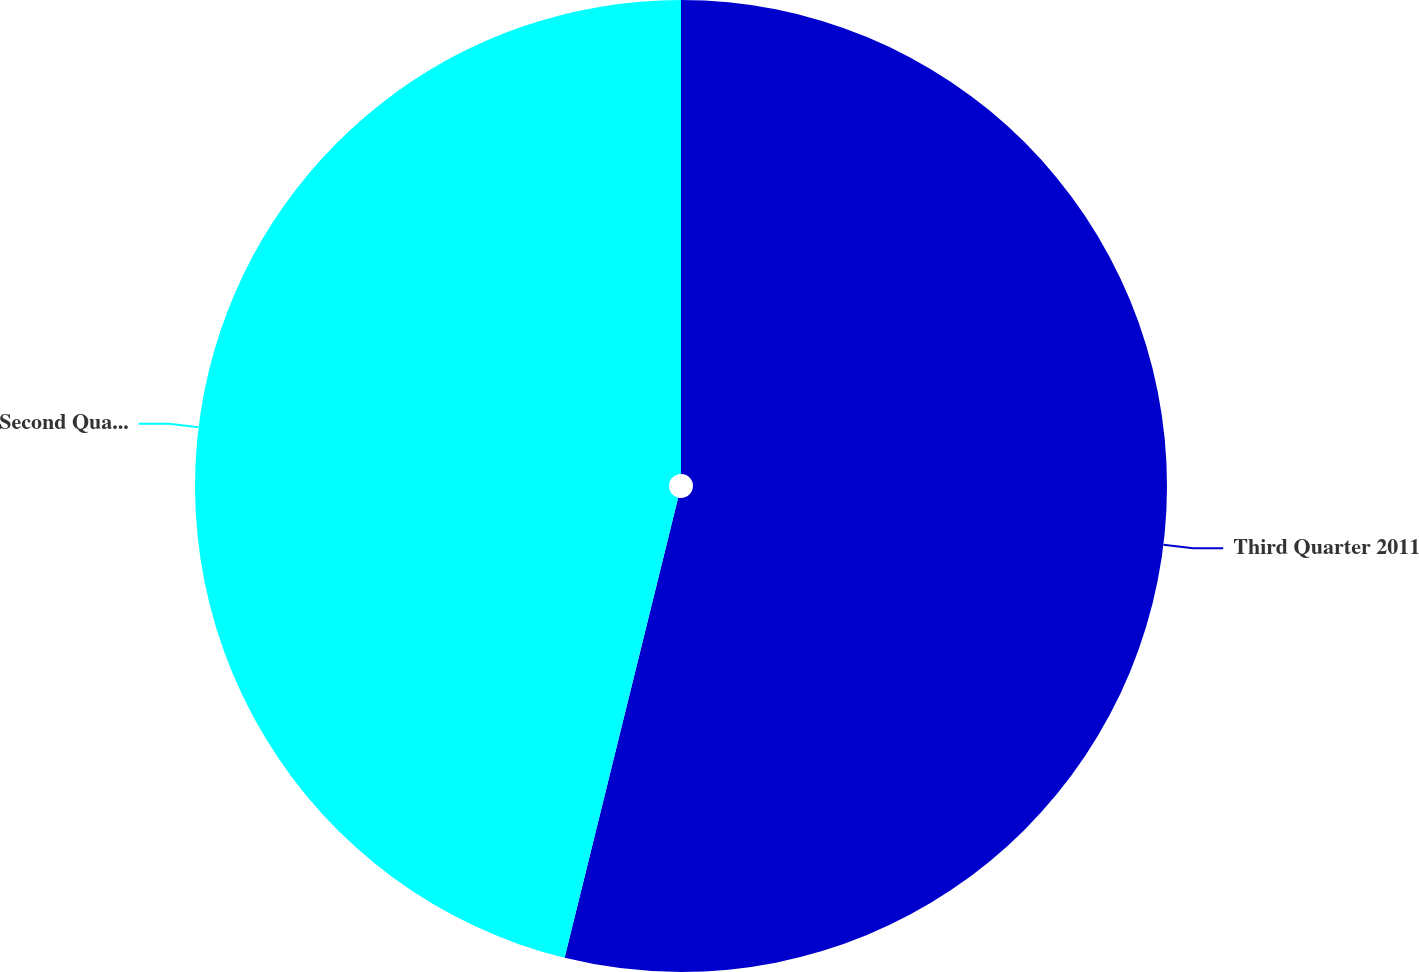Convert chart to OTSL. <chart><loc_0><loc_0><loc_500><loc_500><pie_chart><fcel>Third Quarter 2011<fcel>Second Quarter 2011<nl><fcel>53.85%<fcel>46.15%<nl></chart> 